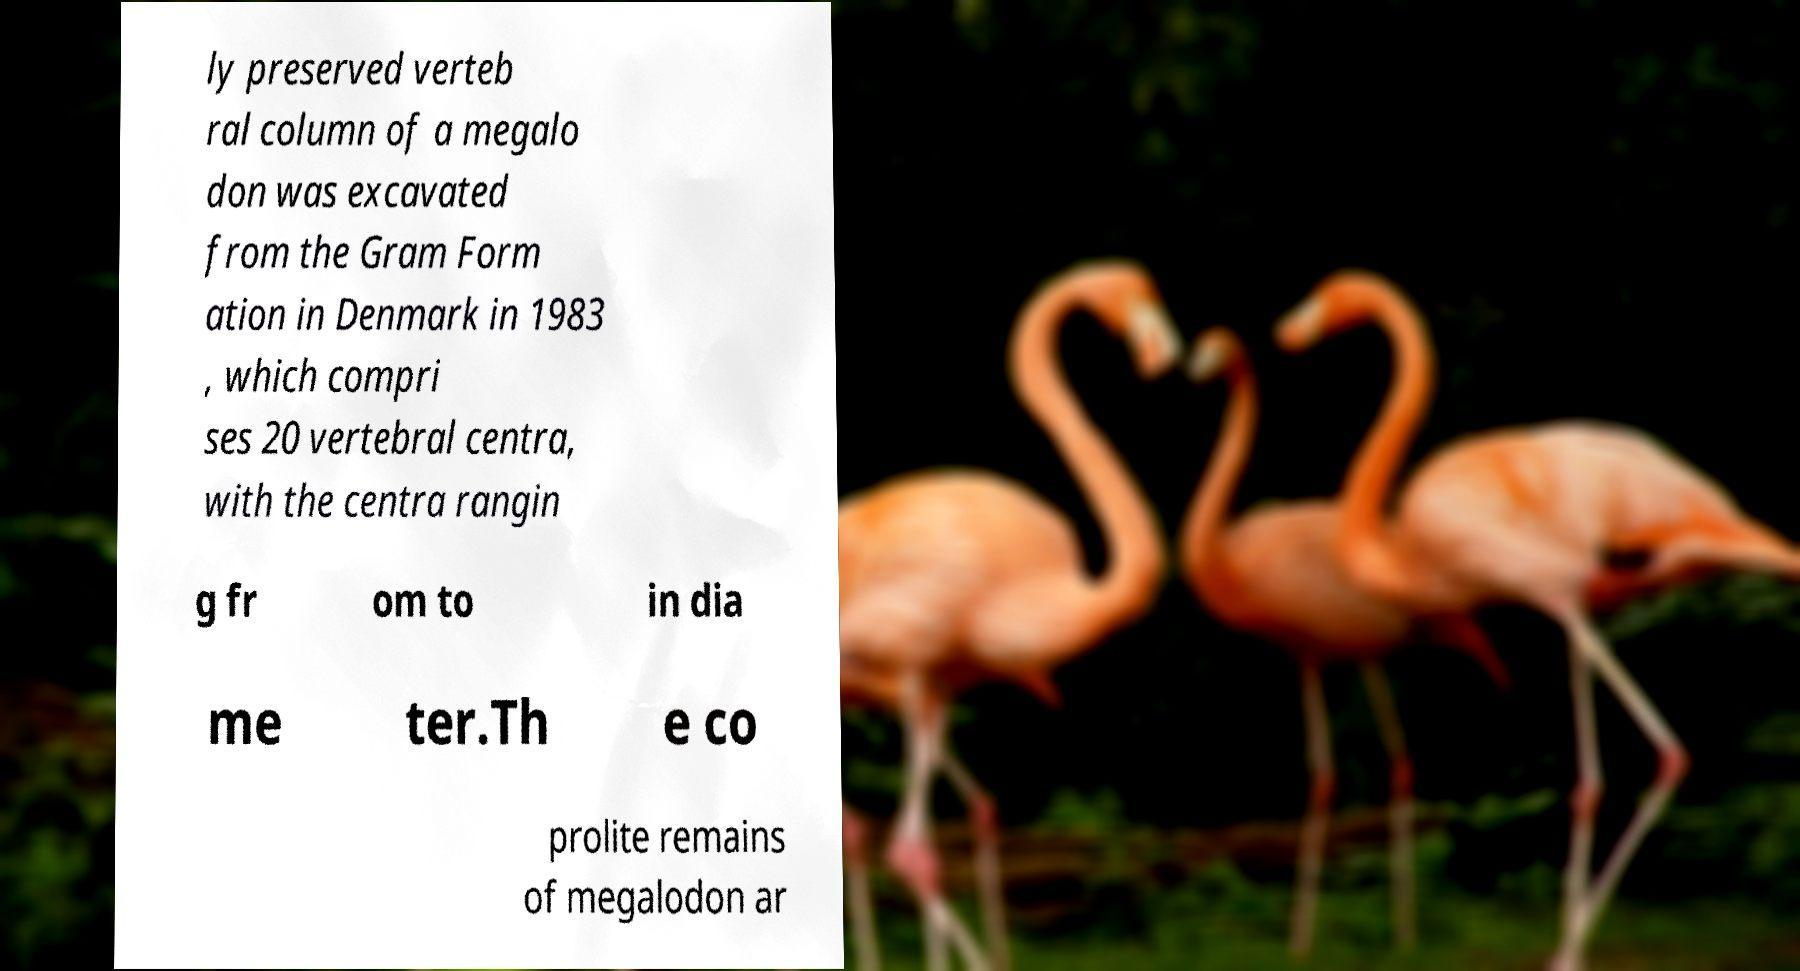Can you read and provide the text displayed in the image?This photo seems to have some interesting text. Can you extract and type it out for me? ly preserved verteb ral column of a megalo don was excavated from the Gram Form ation in Denmark in 1983 , which compri ses 20 vertebral centra, with the centra rangin g fr om to in dia me ter.Th e co prolite remains of megalodon ar 